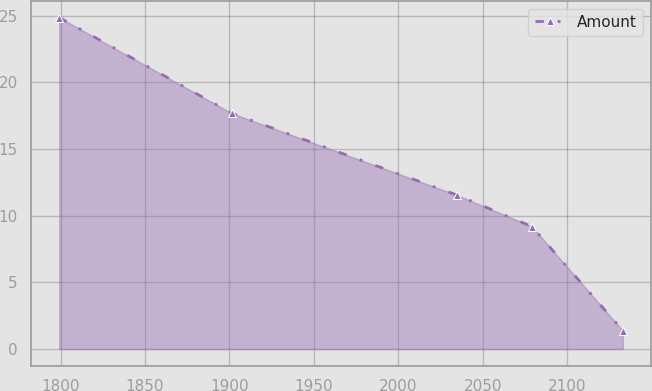Convert chart to OTSL. <chart><loc_0><loc_0><loc_500><loc_500><line_chart><ecel><fcel>Amount<nl><fcel>1799.28<fcel>24.86<nl><fcel>1901.65<fcel>17.67<nl><fcel>2034.94<fcel>11.54<nl><fcel>2079.09<fcel>9.19<nl><fcel>2132.89<fcel>1.39<nl></chart> 